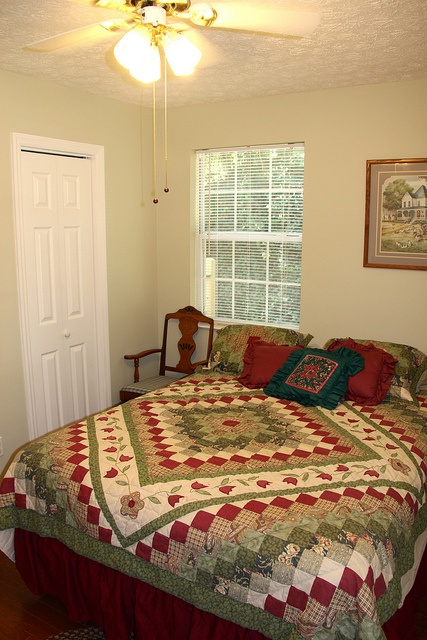Describe the objects in this image and their specific colors. I can see bed in tan, olive, black, and maroon tones and chair in tan, maroon, gray, and black tones in this image. 